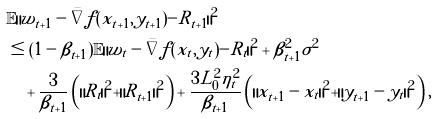<formula> <loc_0><loc_0><loc_500><loc_500>& \mathbb { E } \| w _ { t + 1 } - \bar { \nabla } f ( x _ { t + 1 } , y _ { t + 1 } ) - R _ { t + 1 } \| ^ { 2 } \\ & \leq ( 1 - \beta _ { t + 1 } ) \mathbb { E } \| w _ { t } - \bar { \nabla } f ( x _ { t } , y _ { t } ) - R _ { t } \| ^ { 2 } + \beta ^ { 2 } _ { t + 1 } \sigma ^ { 2 } \\ & \quad + \frac { 3 } { \beta _ { t + 1 } } \left ( \| R _ { t } \| ^ { 2 } + \| R _ { t + 1 } \| ^ { 2 } \right ) + \frac { 3 L ^ { 2 } _ { 0 } \eta ^ { 2 } _ { t } } { \beta _ { t + 1 } } \left ( \| \tilde { x } _ { t + 1 } - x _ { t } \| ^ { 2 } + \| \tilde { y } _ { t + 1 } - y _ { t } \| ^ { 2 } \right ) ,</formula> 